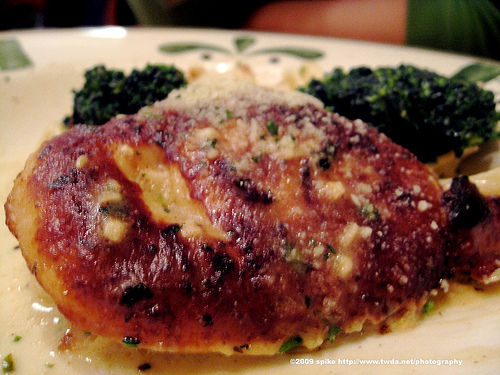Please transcribe the text information in this image. 2009 spike 